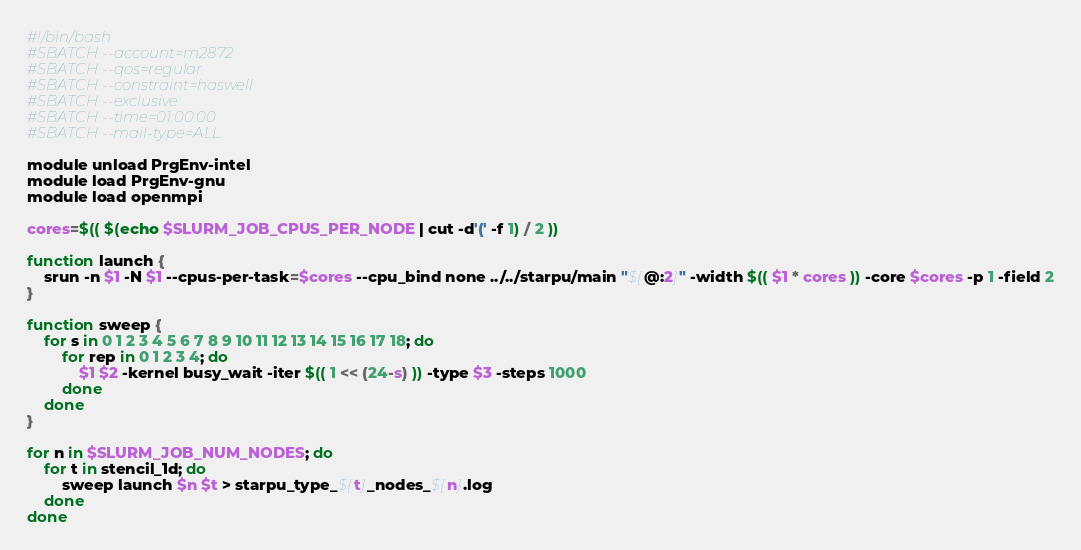Convert code to text. <code><loc_0><loc_0><loc_500><loc_500><_Bash_>#!/bin/bash
#SBATCH --account=m2872
#SBATCH --qos=regular
#SBATCH --constraint=haswell
#SBATCH --exclusive
#SBATCH --time=01:00:00
#SBATCH --mail-type=ALL

module unload PrgEnv-intel
module load PrgEnv-gnu
module load openmpi

cores=$(( $(echo $SLURM_JOB_CPUS_PER_NODE | cut -d'(' -f 1) / 2 ))

function launch {
    srun -n $1 -N $1 --cpus-per-task=$cores --cpu_bind none ../../starpu/main "${@:2}" -width $(( $1 * cores )) -core $cores -p 1 -field 2
}

function sweep {
    for s in 0 1 2 3 4 5 6 7 8 9 10 11 12 13 14 15 16 17 18; do
        for rep in 0 1 2 3 4; do
            $1 $2 -kernel busy_wait -iter $(( 1 << (24-s) )) -type $3 -steps 1000
        done
    done
}

for n in $SLURM_JOB_NUM_NODES; do
    for t in stencil_1d; do
        sweep launch $n $t > starpu_type_${t}_nodes_${n}.log
    done
done
</code> 